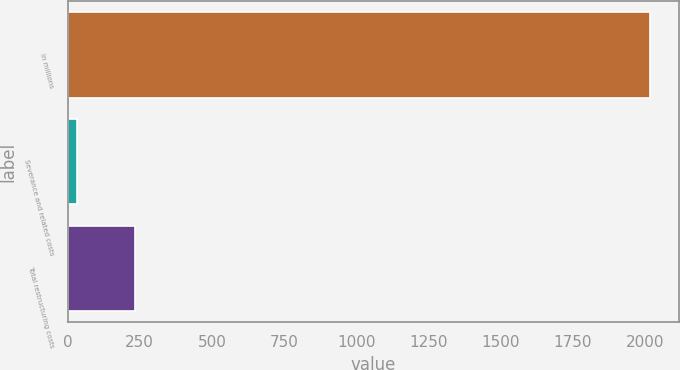Convert chart to OTSL. <chart><loc_0><loc_0><loc_500><loc_500><bar_chart><fcel>In millions<fcel>Severance and related costs<fcel>Total restructuring costs<nl><fcel>2015<fcel>34.5<fcel>232.55<nl></chart> 